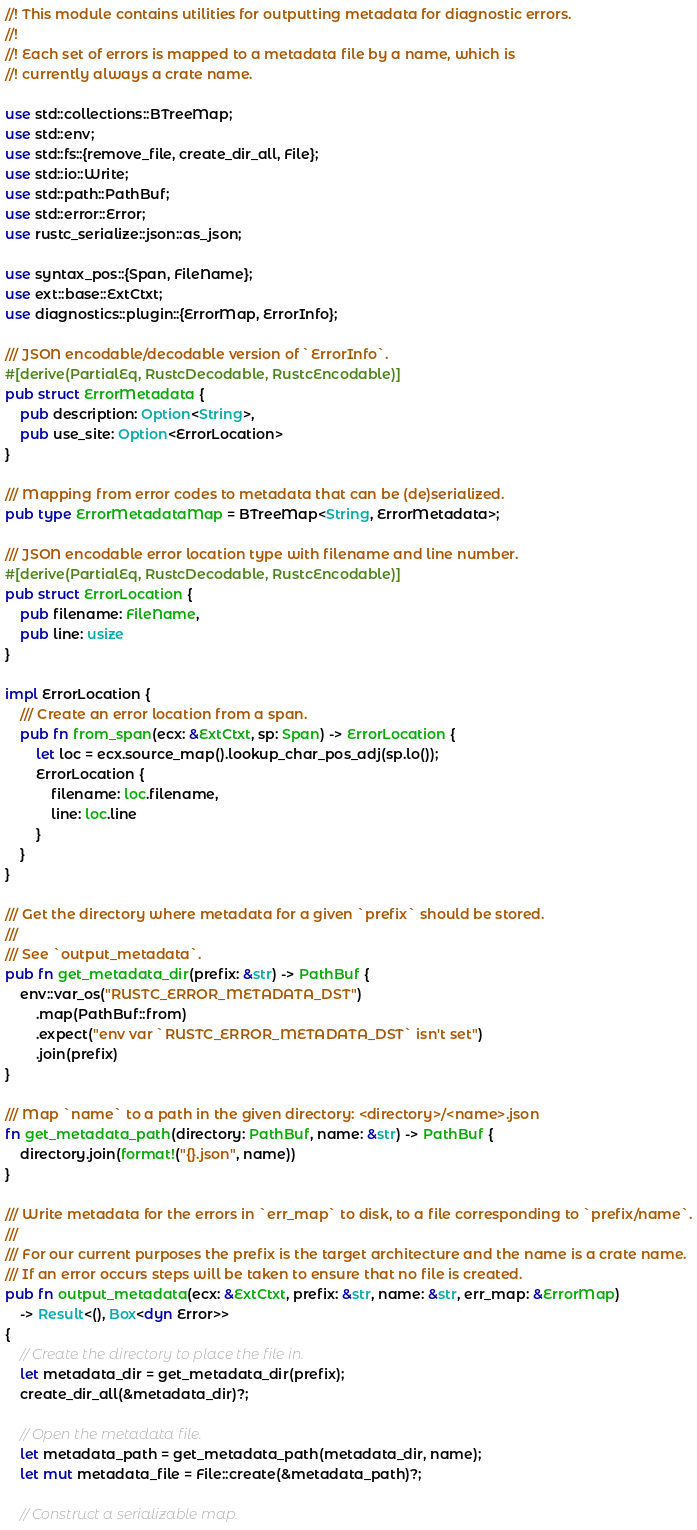<code> <loc_0><loc_0><loc_500><loc_500><_Rust_>//! This module contains utilities for outputting metadata for diagnostic errors.
//!
//! Each set of errors is mapped to a metadata file by a name, which is
//! currently always a crate name.

use std::collections::BTreeMap;
use std::env;
use std::fs::{remove_file, create_dir_all, File};
use std::io::Write;
use std::path::PathBuf;
use std::error::Error;
use rustc_serialize::json::as_json;

use syntax_pos::{Span, FileName};
use ext::base::ExtCtxt;
use diagnostics::plugin::{ErrorMap, ErrorInfo};

/// JSON encodable/decodable version of `ErrorInfo`.
#[derive(PartialEq, RustcDecodable, RustcEncodable)]
pub struct ErrorMetadata {
    pub description: Option<String>,
    pub use_site: Option<ErrorLocation>
}

/// Mapping from error codes to metadata that can be (de)serialized.
pub type ErrorMetadataMap = BTreeMap<String, ErrorMetadata>;

/// JSON encodable error location type with filename and line number.
#[derive(PartialEq, RustcDecodable, RustcEncodable)]
pub struct ErrorLocation {
    pub filename: FileName,
    pub line: usize
}

impl ErrorLocation {
    /// Create an error location from a span.
    pub fn from_span(ecx: &ExtCtxt, sp: Span) -> ErrorLocation {
        let loc = ecx.source_map().lookup_char_pos_adj(sp.lo());
        ErrorLocation {
            filename: loc.filename,
            line: loc.line
        }
    }
}

/// Get the directory where metadata for a given `prefix` should be stored.
///
/// See `output_metadata`.
pub fn get_metadata_dir(prefix: &str) -> PathBuf {
    env::var_os("RUSTC_ERROR_METADATA_DST")
        .map(PathBuf::from)
        .expect("env var `RUSTC_ERROR_METADATA_DST` isn't set")
        .join(prefix)
}

/// Map `name` to a path in the given directory: <directory>/<name>.json
fn get_metadata_path(directory: PathBuf, name: &str) -> PathBuf {
    directory.join(format!("{}.json", name))
}

/// Write metadata for the errors in `err_map` to disk, to a file corresponding to `prefix/name`.
///
/// For our current purposes the prefix is the target architecture and the name is a crate name.
/// If an error occurs steps will be taken to ensure that no file is created.
pub fn output_metadata(ecx: &ExtCtxt, prefix: &str, name: &str, err_map: &ErrorMap)
    -> Result<(), Box<dyn Error>>
{
    // Create the directory to place the file in.
    let metadata_dir = get_metadata_dir(prefix);
    create_dir_all(&metadata_dir)?;

    // Open the metadata file.
    let metadata_path = get_metadata_path(metadata_dir, name);
    let mut metadata_file = File::create(&metadata_path)?;

    // Construct a serializable map.</code> 